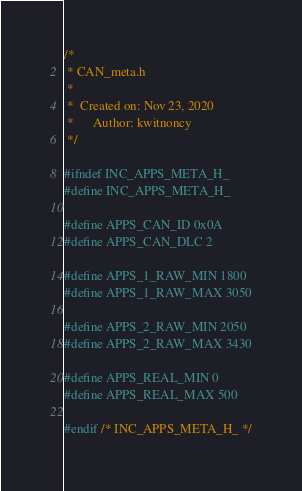Convert code to text. <code><loc_0><loc_0><loc_500><loc_500><_C_>/*
 * CAN_meta.h
 *
 *  Created on: Nov 23, 2020
 *      Author: kwitnoncy
 */

#ifndef INC_APPS_META_H_
#define INC_APPS_META_H_

#define APPS_CAN_ID 0x0A
#define APPS_CAN_DLC 2

#define APPS_1_RAW_MIN 1800
#define APPS_1_RAW_MAX 3050

#define APPS_2_RAW_MIN 2050
#define APPS_2_RAW_MAX 3430

#define APPS_REAL_MIN 0
#define APPS_REAL_MAX 500

#endif /* INC_APPS_META_H_ */
</code> 